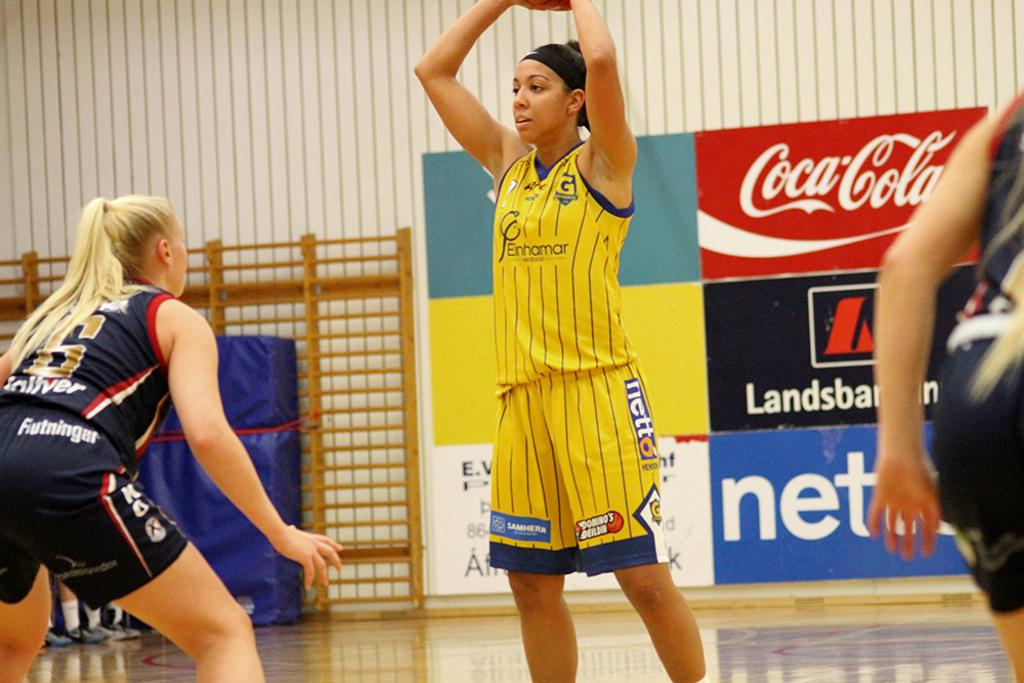Provide a one-sentence caption for the provided image. two women's basketball teams playing on a court sponsored by coca cola. 